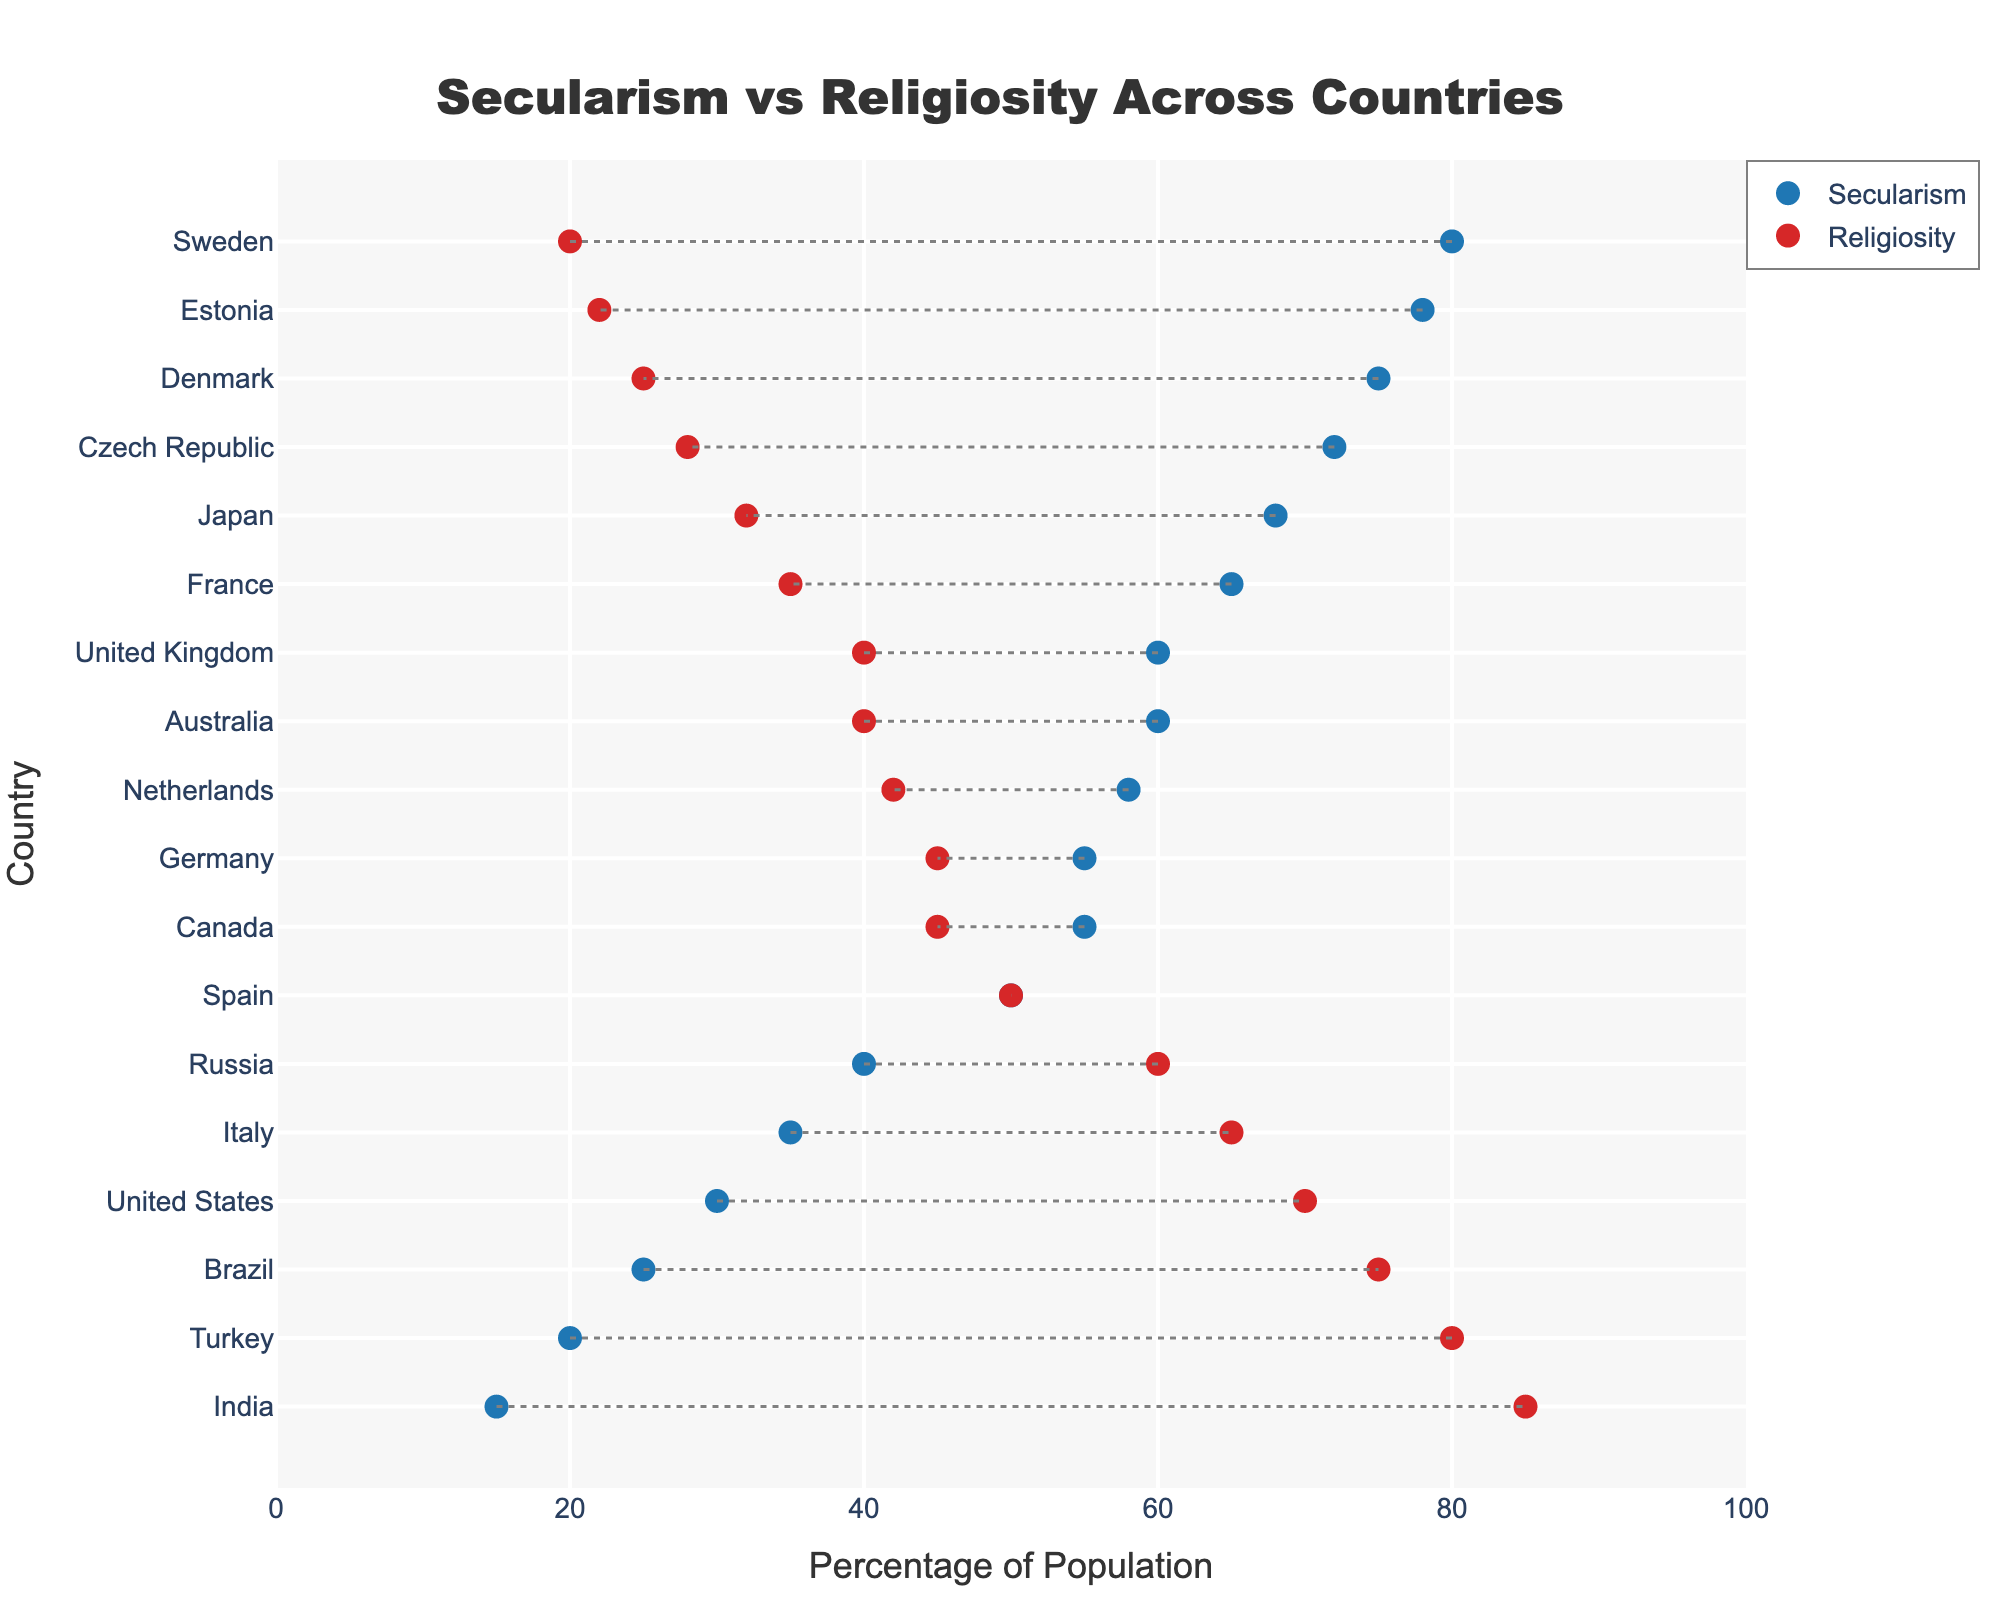What's the title of the plot? The title of the plot is located at the top center of the figure and reads "Secularism vs Religiosity Across Countries."
Answer: Secularism vs Religiosity Across Countries Which country has the highest percentage of secular population? The country with the highest percentage of secular population is placed at the uppermost position of the y-axis, which in this plot is Sweden at 80%.
Answer: Sweden What is the percentage of religiosity in Brazil? To find this, locate Brazil on the y-axis and check the corresponding marker on the x-axis for religiosity. Brazil is at 75%.
Answer: 75% Which countries have an equal percentage of secular and religious populations? This requires identifying the countries where the markers for secularism and religiosity lie on the same vertical line, which means they are both at 50%. Only Spain has equal percentages at 50%.
Answer: Spain What is the average percentage of secularism for Sweden, Denmark, and Estonia? Sweden, Denmark, and Estonia have secularism percentages of 80%, 75%, and 78% respectively. The average is calculated as (80 + 75 + 78) / 3 = 77.67%.
Answer: 77.67% Which country has a higher percentage of religiosity, Italy or Germany? Look at the markers for Italy and Germany on the religiosity axis. Italy is at 65%, and Germany is at 45%. Therefore, Italy has a higher religiosity percentage.
Answer: Italy What is the difference in secularism between the United States and France? The United States has a secularism percentage of 30%, and France has 65%. The difference is 65 - 30 = 35%.
Answer: 35% Based on the plot, which region would you infer to be more secular: Northern Europe or South America? Northern European countries like Sweden, Denmark, and Estonia have high secularism percentages (80%, 75%, and 78%). In contrast, South American countries like Brazil have low secularism percentages (25%). Therefore, Northern Europe is inferred to be more secular.
Answer: Northern Europe Which country has the smallest gap between secularism and religiosity? To find the smallest gap, look for the country where the dotted line connecting the secularism and religiosity markers is shortest. Russia has a small gap with 40% secularism and 60% religiosity, a difference of 20%.
Answer: Russia What is the total percentage share of religiosity for India, Turkey, and Russia combined? India, Turkey, and Russia have religiosity percentages of 85%, 80%, and 60% respectively. The total is calculated as 85 + 80 + 60 = 225%.
Answer: 225% 